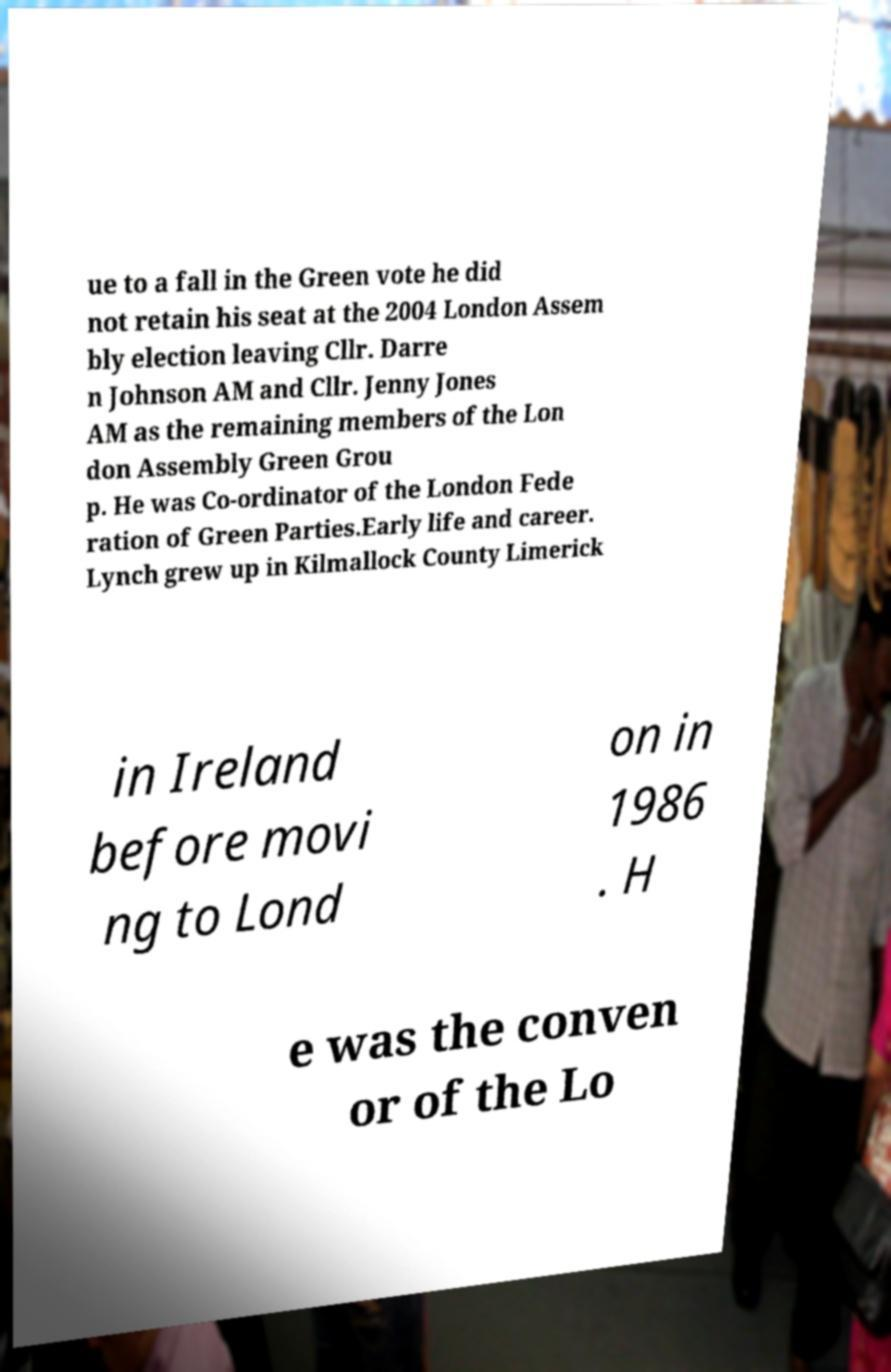Please identify and transcribe the text found in this image. ue to a fall in the Green vote he did not retain his seat at the 2004 London Assem bly election leaving Cllr. Darre n Johnson AM and Cllr. Jenny Jones AM as the remaining members of the Lon don Assembly Green Grou p. He was Co-ordinator of the London Fede ration of Green Parties.Early life and career. Lynch grew up in Kilmallock County Limerick in Ireland before movi ng to Lond on in 1986 . H e was the conven or of the Lo 